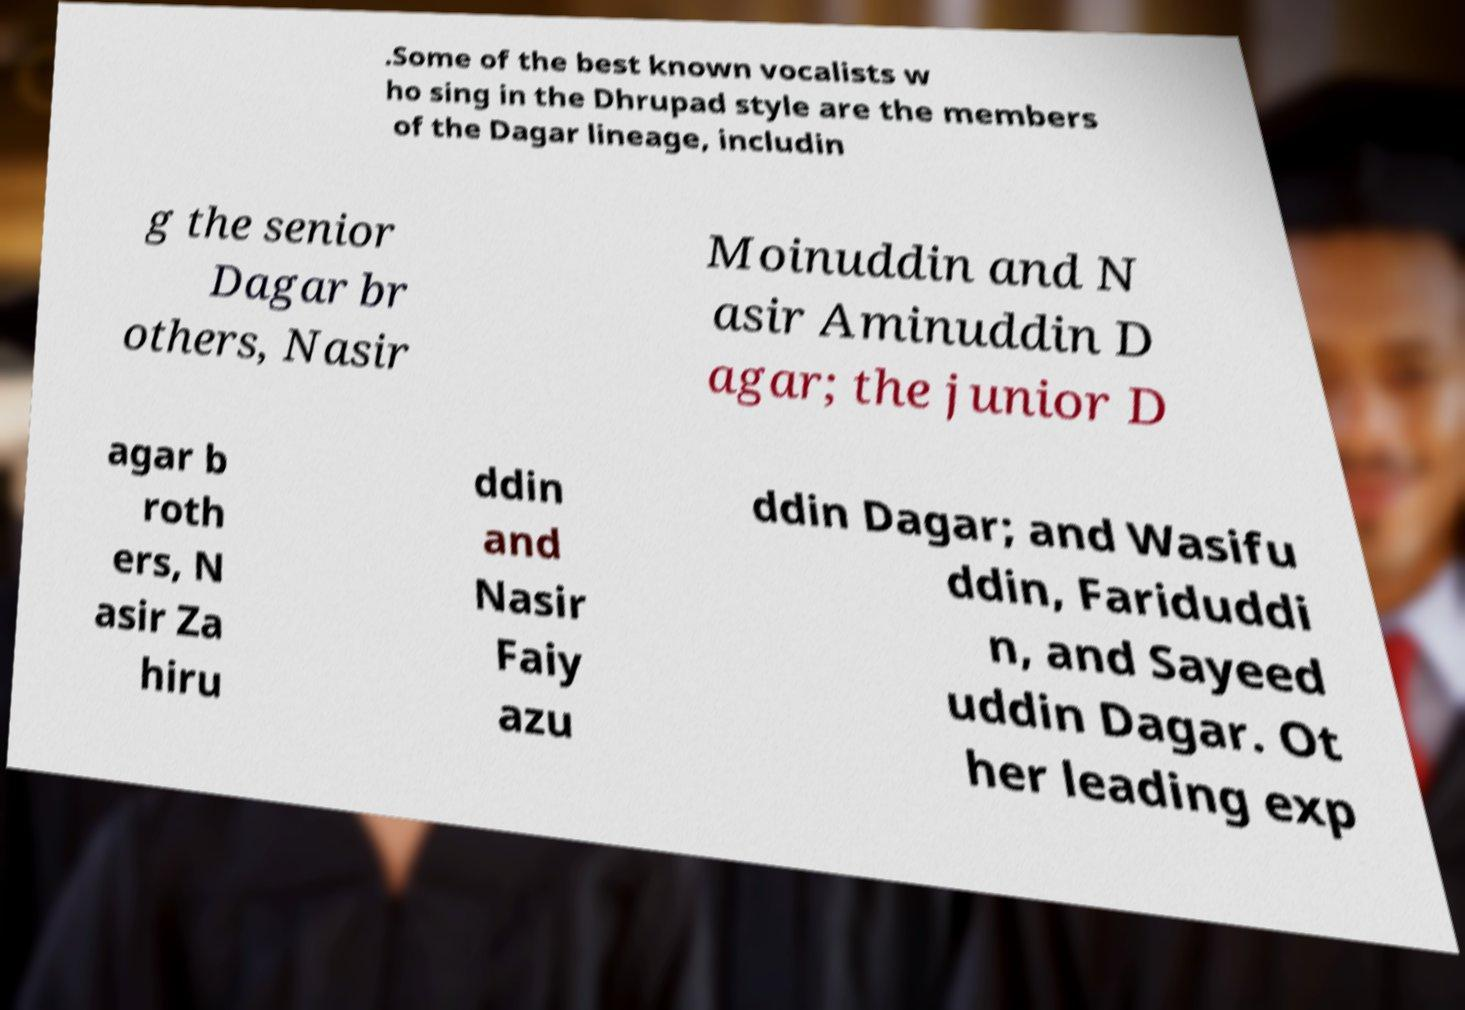Can you accurately transcribe the text from the provided image for me? .Some of the best known vocalists w ho sing in the Dhrupad style are the members of the Dagar lineage, includin g the senior Dagar br others, Nasir Moinuddin and N asir Aminuddin D agar; the junior D agar b roth ers, N asir Za hiru ddin and Nasir Faiy azu ddin Dagar; and Wasifu ddin, Fariduddi n, and Sayeed uddin Dagar. Ot her leading exp 